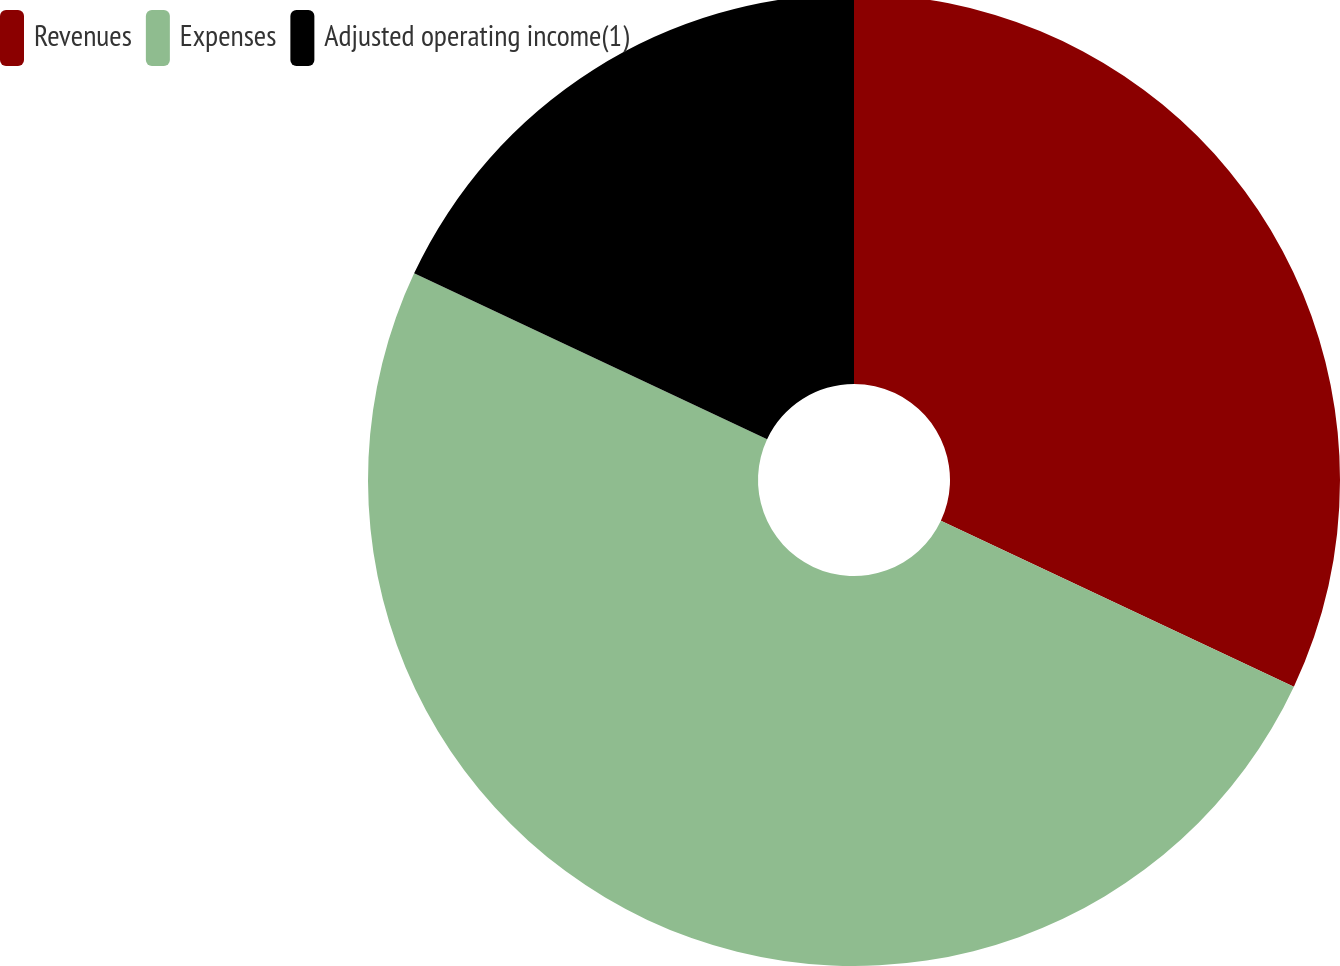<chart> <loc_0><loc_0><loc_500><loc_500><pie_chart><fcel>Revenues<fcel>Expenses<fcel>Adjusted operating income(1)<nl><fcel>31.99%<fcel>50.0%<fcel>18.01%<nl></chart> 